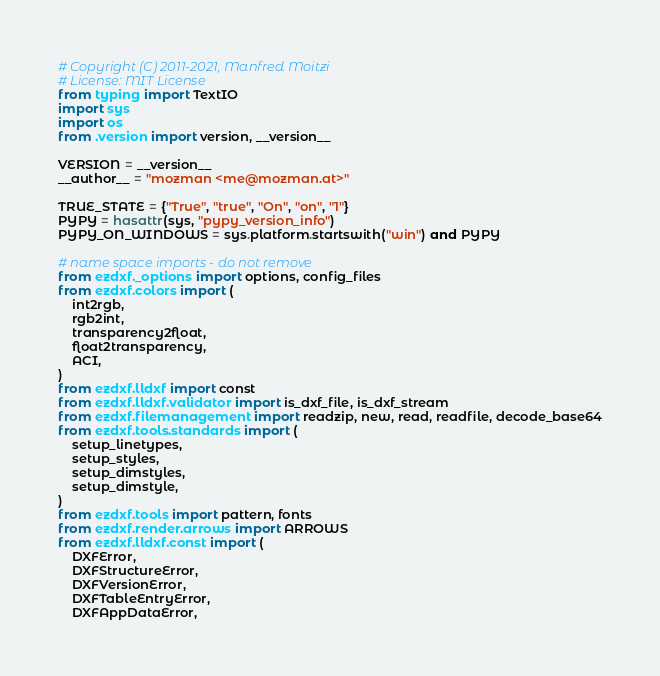Convert code to text. <code><loc_0><loc_0><loc_500><loc_500><_Python_># Copyright (C) 2011-2021, Manfred Moitzi
# License: MIT License
from typing import TextIO
import sys
import os
from .version import version, __version__

VERSION = __version__
__author__ = "mozman <me@mozman.at>"

TRUE_STATE = {"True", "true", "On", "on", "1"}
PYPY = hasattr(sys, "pypy_version_info")
PYPY_ON_WINDOWS = sys.platform.startswith("win") and PYPY

# name space imports - do not remove
from ezdxf._options import options, config_files
from ezdxf.colors import (
    int2rgb,
    rgb2int,
    transparency2float,
    float2transparency,
    ACI,
)
from ezdxf.lldxf import const
from ezdxf.lldxf.validator import is_dxf_file, is_dxf_stream
from ezdxf.filemanagement import readzip, new, read, readfile, decode_base64
from ezdxf.tools.standards import (
    setup_linetypes,
    setup_styles,
    setup_dimstyles,
    setup_dimstyle,
)
from ezdxf.tools import pattern, fonts
from ezdxf.render.arrows import ARROWS
from ezdxf.lldxf.const import (
    DXFError,
    DXFStructureError,
    DXFVersionError,
    DXFTableEntryError,
    DXFAppDataError,</code> 